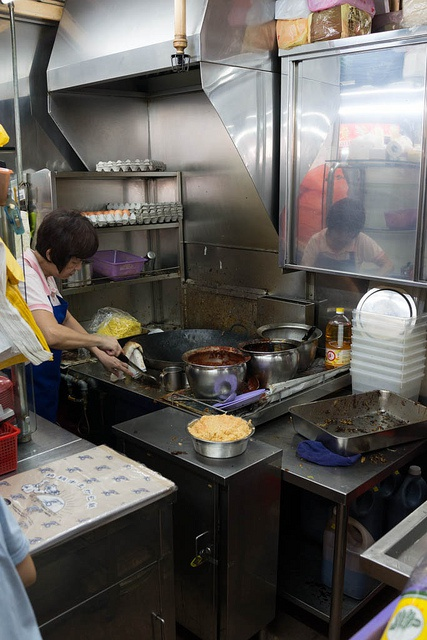Describe the objects in this image and their specific colors. I can see oven in black, gray, and darkgray tones, people in black, tan, gray, and lightgray tones, people in black and gray tones, bowl in black, gray, and maroon tones, and bowl in black, tan, gray, and darkgray tones in this image. 